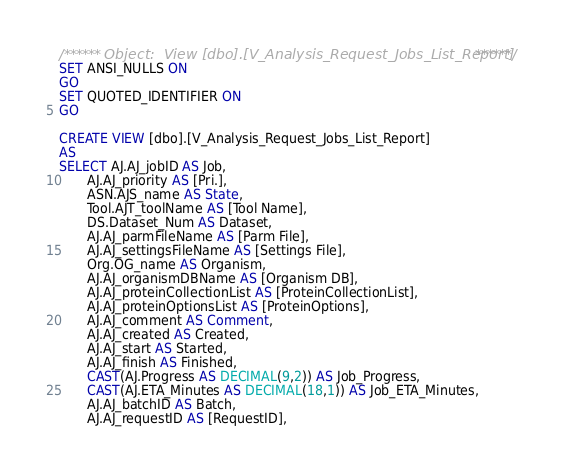<code> <loc_0><loc_0><loc_500><loc_500><_SQL_>/****** Object:  View [dbo].[V_Analysis_Request_Jobs_List_Report] ******/
SET ANSI_NULLS ON
GO
SET QUOTED_IDENTIFIER ON
GO

CREATE VIEW [dbo].[V_Analysis_Request_Jobs_List_Report]
AS
SELECT AJ.AJ_jobID AS Job,
       AJ.AJ_priority AS [Pri.],
       ASN.AJS_name AS State,
       Tool.AJT_toolName AS [Tool Name],
       DS.Dataset_Num AS Dataset,
       AJ.AJ_parmFileName AS [Parm File],
       AJ.AJ_settingsFileName AS [Settings File],
       Org.OG_name AS Organism,
       AJ.AJ_organismDBName AS [Organism DB],
       AJ.AJ_proteinCollectionList AS [ProteinCollectionList],
       AJ.AJ_proteinOptionsList AS [ProteinOptions],
       AJ.AJ_comment AS Comment,
       AJ.AJ_created AS Created,
       AJ.AJ_start AS Started,
       AJ.AJ_finish AS Finished,
	   CAST(AJ.Progress AS DECIMAL(9,2)) AS Job_Progress,
	   CAST(AJ.ETA_Minutes AS DECIMAL(18,1)) AS Job_ETA_Minutes,
       AJ.AJ_batchID AS Batch,
       AJ.AJ_requestID AS [RequestID],</code> 